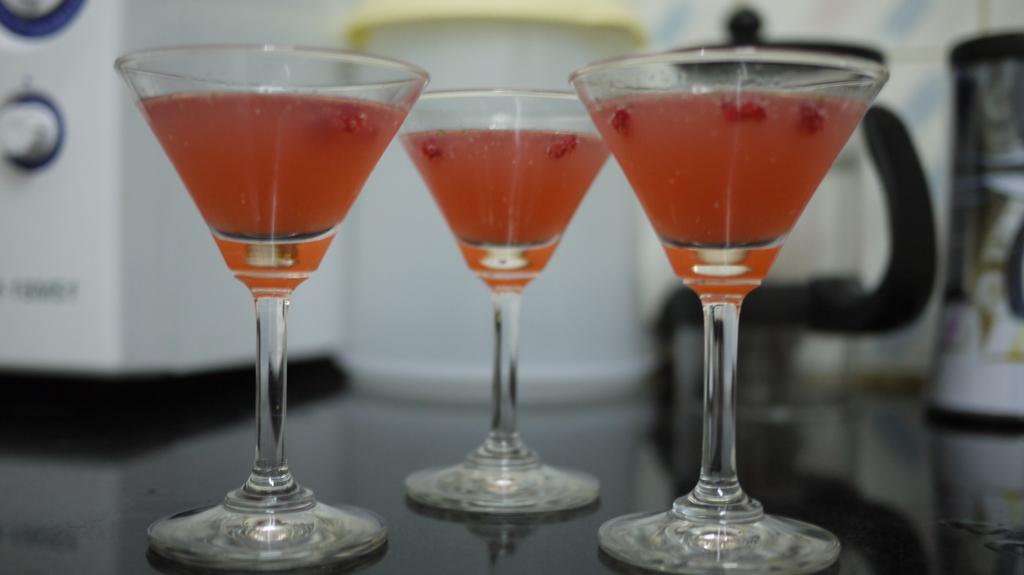In one or two sentences, can you explain what this image depicts? In this image there are three glasses kept one beside the other. In the glasses there is some drink. In the background there is a machine. On the right side there are jars in the background. 